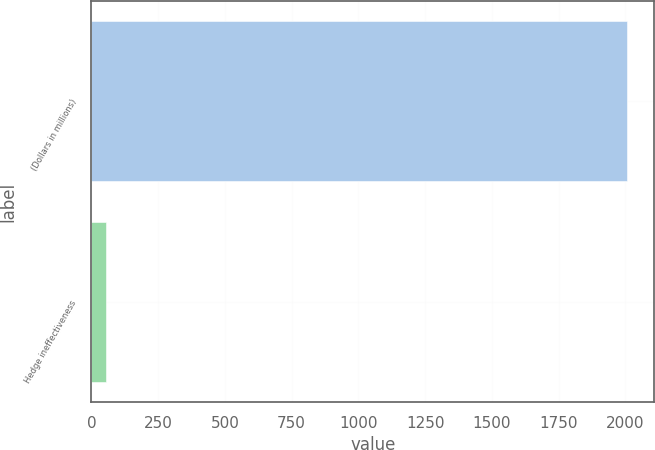<chart> <loc_0><loc_0><loc_500><loc_500><bar_chart><fcel>(Dollars in millions)<fcel>Hedge ineffectiveness<nl><fcel>2007<fcel>55<nl></chart> 